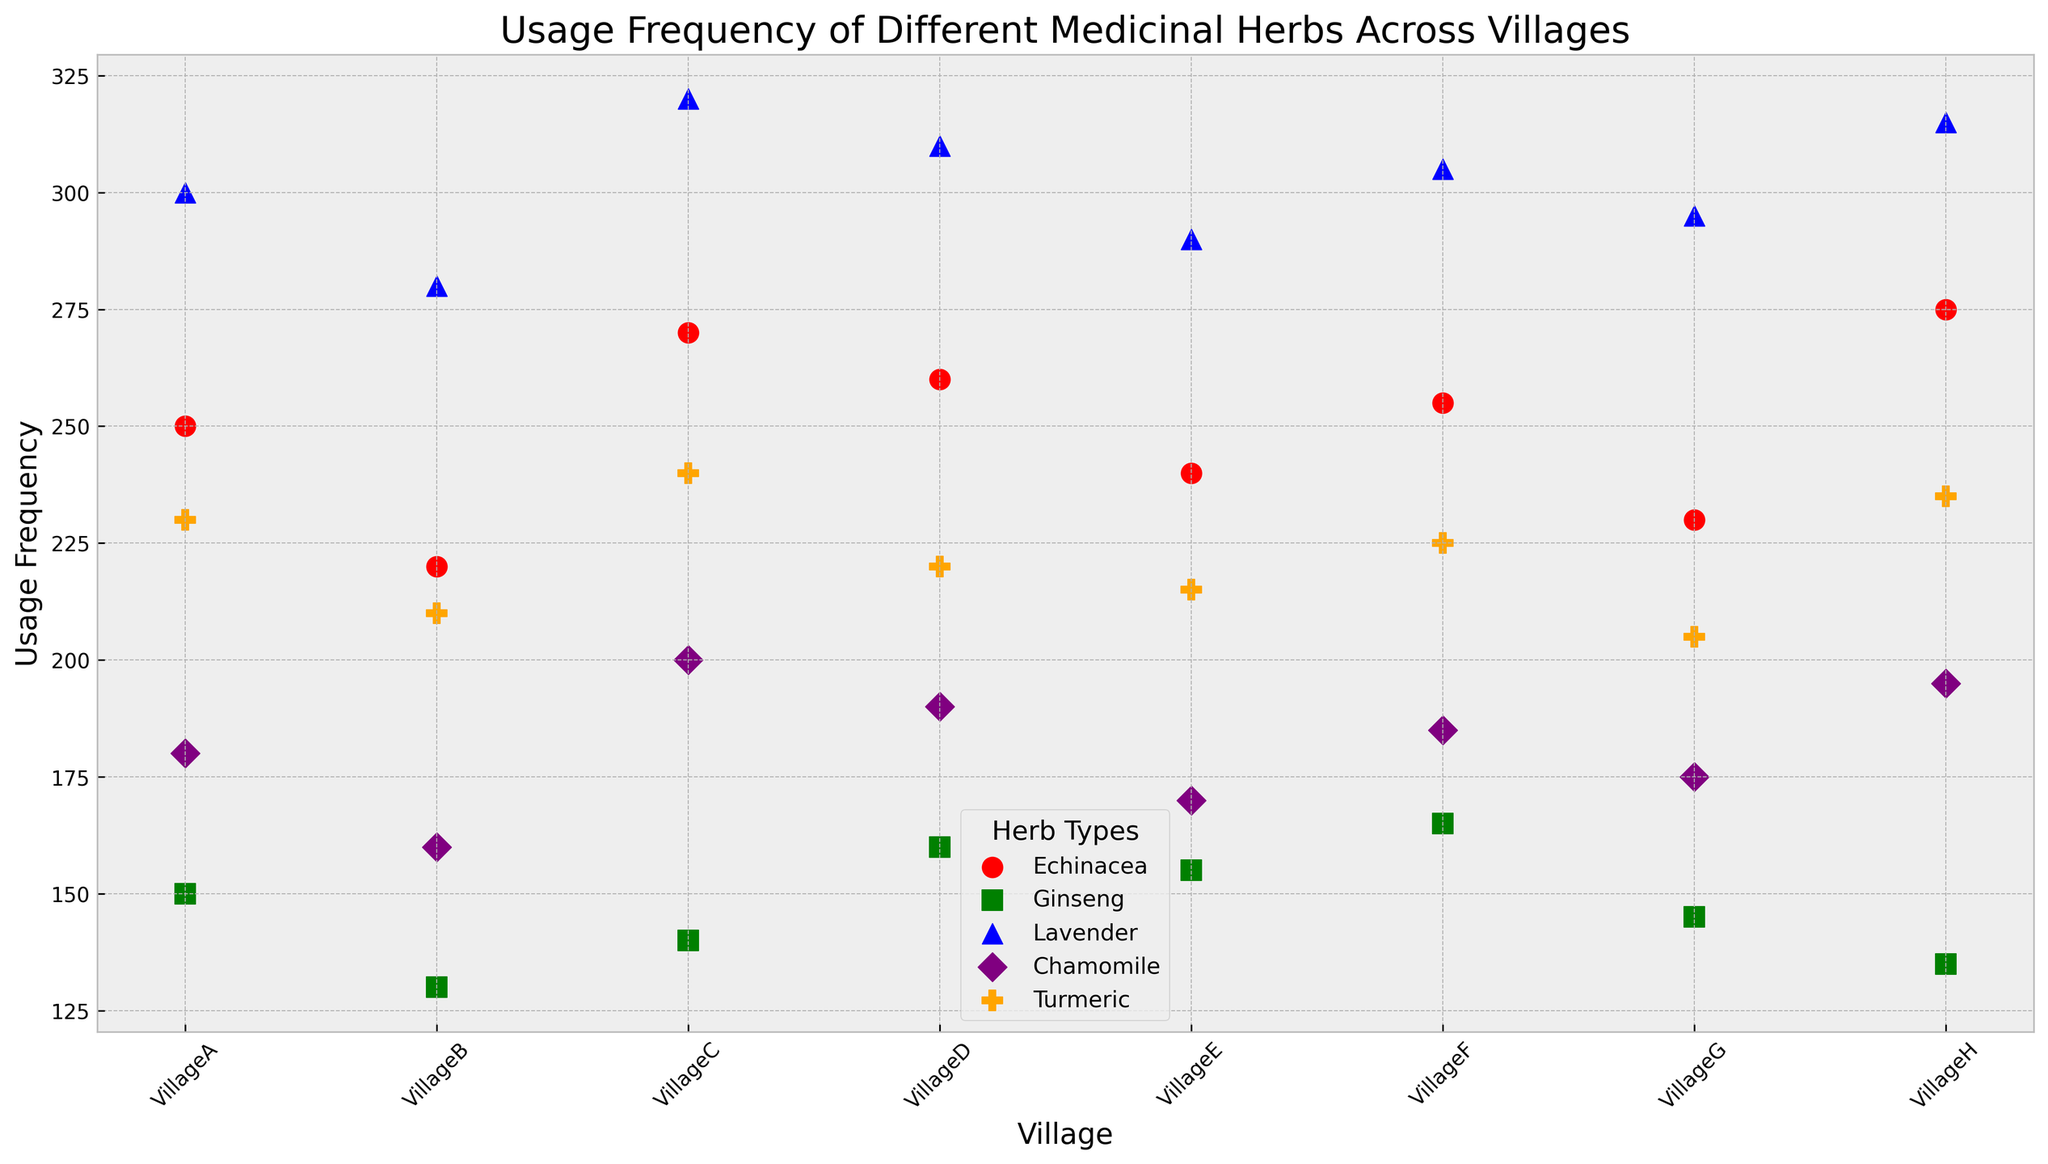Which village has the highest usage frequency of Lavender? To find the village with the highest usage frequency of Lavender, look for the blue markers on the scatter plot and identify the highest point among them. This would be the village where Lavender is used the most.
Answer: VillageC How does the usage frequency of Echinacea in VillageH compare to that in VillageA? Locate the red markers corresponding to Echinacea for VillageH and VillageA. Compare the heights of these markers to determine which village has a higher frequency.
Answer: VillageH is higher Which herb shows the most consistent usage frequency across all villages? To determine consistency, observe which colored markers are most closely aligned horizontally. This would indicate similar usage frequencies across different villages.
Answer: Chamomile What is the average usage frequency of Chamomile across all villages? Identify the purple markers representing Chamomile. Sum up their UsageFrequency values (180+160+200+190+170+185+175+195), then divide by the number of villages (8).
Answer: 182.5 Which village has the lowest usage frequency of Ginseng? Find the green markers corresponding to Ginseng across all villages, and identify the lowest point. This indicates the village with the least Ginseng usage.
Answer: VillageH Compare the usage frequencies of Turmeric and Lavender in VillageG. Which one is higher? Locate the markers for Turmeric (orange) and Lavender (blue) in VillageG and compare their heights to see which one is taller.
Answer: Lavender is higher Calculate the total usage frequency of Echinacea across the villages. Sum up the usage frequencies of Echinacea (250+220+270+260+240+255+230+275).
Answer: 2000 Which two herbs show the biggest difference in usage frequency in VillageF? Compare the markers for all herbs in VillageF to see which two have the largest vertical distance between them.
Answer: Lavender and Ginseng What color represents the herb with the second highest average usage frequency across all villages? Calculate the average usage frequencies for each herb and determine which one is the second highest. Refer to the color associated with that herb.
Answer: Orange (Turmeric) Which village shows a higher frequency for Chamomile than Turmeric? For each village, compare the purple marker (Chamomile) and orange marker (Turmeric) and check if Chamomile's marker is higher.
Answer: VillageA, VillageC, VillageD, VillageF, VillageG, VillageH 